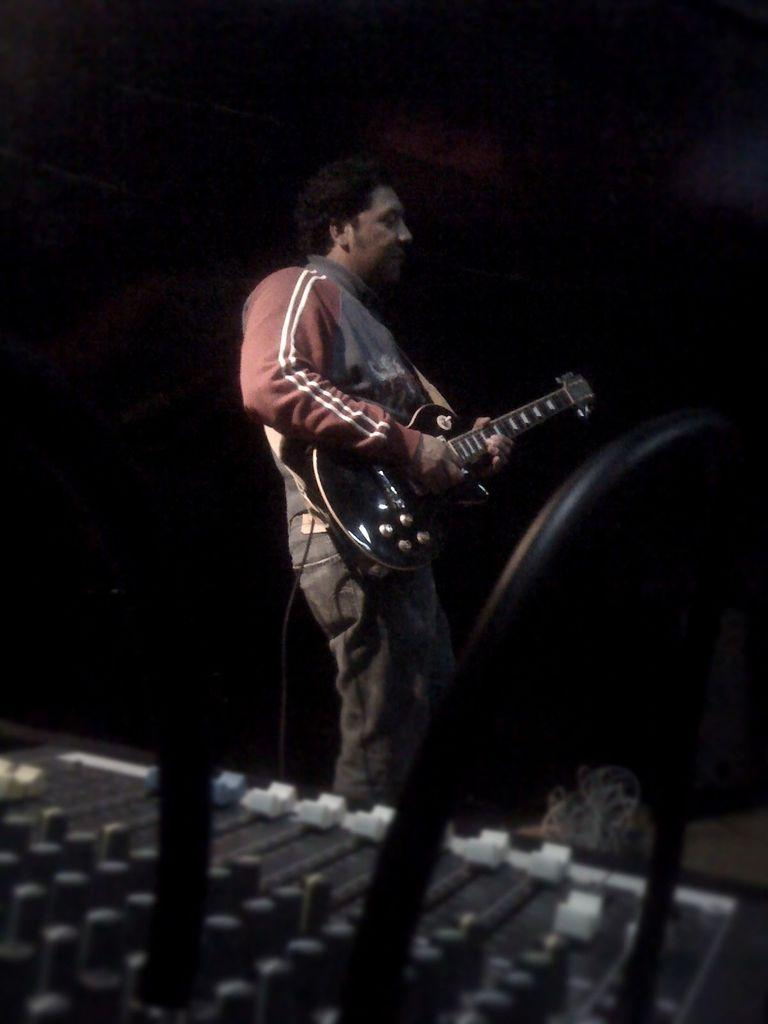Who or what is the main subject of the image? There is a person in the image. Where is the person located in the image? The person is standing in the center of the image. What is the person holding in his hand? The person is holding a guitar in his hand. What type of ornament is hanging from the guitar in the image? There is no ornament hanging from the guitar in the image; the person is simply holding a guitar. Is the person in the image conducting a business transaction? There is no indication of a business transaction in the image; the person is holding a guitar, which suggests they might be a musician or performer. 